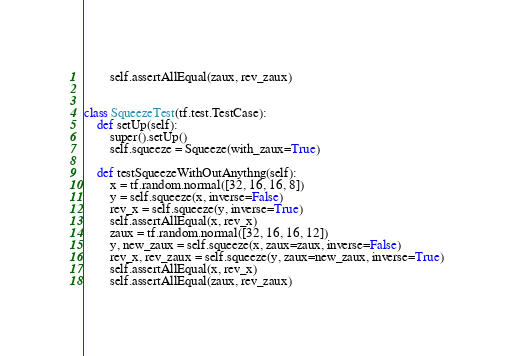<code> <loc_0><loc_0><loc_500><loc_500><_Python_>        self.assertAllEqual(zaux, rev_zaux)


class SqueezeTest(tf.test.TestCase):
    def setUp(self):
        super().setUp()
        self.squeeze = Squeeze(with_zaux=True)

    def testSqueezeWithOutAnythng(self):
        x = tf.random.normal([32, 16, 16, 8])
        y = self.squeeze(x, inverse=False)
        rev_x = self.squeeze(y, inverse=True)
        self.assertAllEqual(x, rev_x)
        zaux = tf.random.normal([32, 16, 16, 12])
        y, new_zaux = self.squeeze(x, zaux=zaux, inverse=False)
        rev_x, rev_zaux = self.squeeze(y, zaux=new_zaux, inverse=True)
        self.assertAllEqual(x, rev_x)
        self.assertAllEqual(zaux, rev_zaux)
</code> 